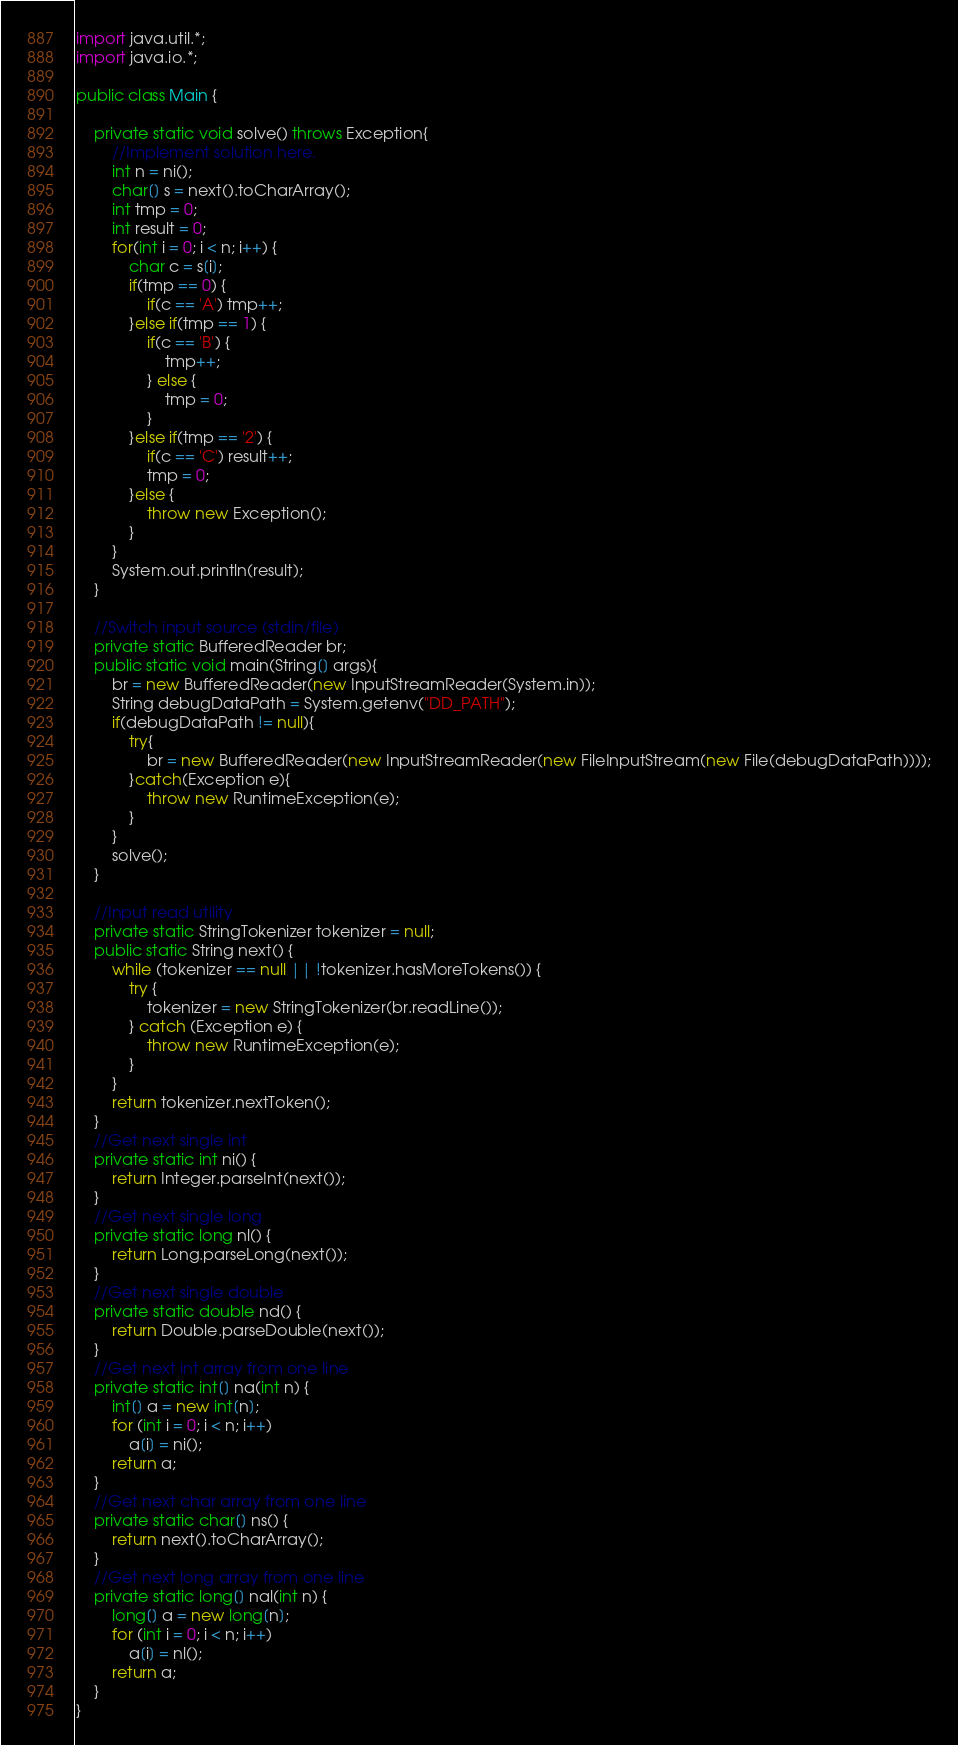<code> <loc_0><loc_0><loc_500><loc_500><_Java_>import java.util.*;
import java.io.*;

public class Main {

	private static void solve() throws Exception{
		//Implement solution here.
		int n = ni();
		char[] s = next().toCharArray();
		int tmp = 0;
		int result = 0;
		for(int i = 0; i < n; i++) {
			char c = s[i];
			if(tmp == 0) {
				if(c == 'A') tmp++;
			}else if(tmp == 1) {
				if(c == 'B') {
					tmp++;
				} else {
					tmp = 0;
				}
			}else if(tmp == '2') {
				if(c == 'C') result++;
				tmp = 0;
			}else {
				throw new Exception();
			}
		}
		System.out.println(result);
	}

	//Switch input source (stdin/file)
	private static BufferedReader br;
	public static void main(String[] args){
		br = new BufferedReader(new InputStreamReader(System.in));
		String debugDataPath = System.getenv("DD_PATH");        
		if(debugDataPath != null){
			try{
				br = new BufferedReader(new InputStreamReader(new FileInputStream(new File(debugDataPath))));
			}catch(Exception e){
				throw new RuntimeException(e);
			}
		}
		solve();
	}

	//Input read utility
	private static StringTokenizer tokenizer = null;
	public static String next() {
		while (tokenizer == null || !tokenizer.hasMoreTokens()) {
			try {
				tokenizer = new StringTokenizer(br.readLine());
			} catch (Exception e) {
				throw new RuntimeException(e);
			}
		}
		return tokenizer.nextToken();
	}
	//Get next single int
	private static int ni() {
		return Integer.parseInt(next());
	}
	//Get next single long
	private static long nl() {
		return Long.parseLong(next());
	}
	//Get next single double
	private static double nd() {
		return Double.parseDouble(next());
	}
	//Get next int array from one line
	private static int[] na(int n) {
		int[] a = new int[n];
		for (int i = 0; i < n; i++)
			a[i] = ni();
		return a;
	}
	//Get next char array from one line
	private static char[] ns() {
		return next().toCharArray();
	}
	//Get next long array from one line
	private static long[] nal(int n) {
		long[] a = new long[n];
		for (int i = 0; i < n; i++)
			a[i] = nl();
		return a;
	}
}
</code> 